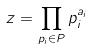<formula> <loc_0><loc_0><loc_500><loc_500>z = \prod _ { p _ { i } \in P } p _ { i } ^ { a _ { i } }</formula> 